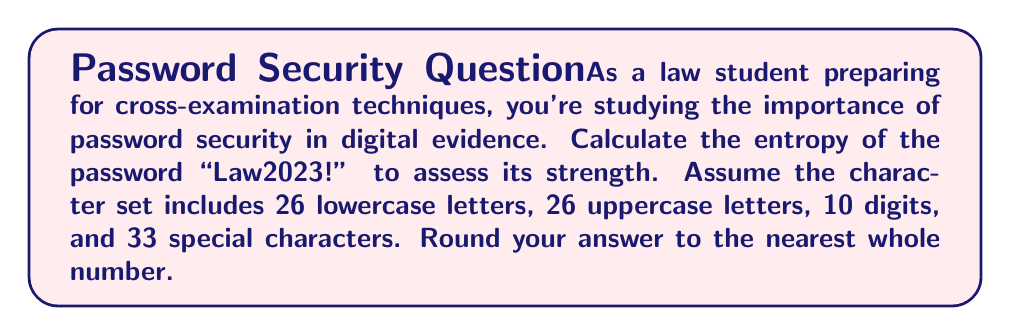Could you help me with this problem? To calculate the entropy of a password, we use the formula:

$$H = L \times \log_2(R)$$

Where:
$H$ = entropy in bits
$L$ = length of the password
$R$ = size of the character set

Step 1: Determine the length of the password (L)
The password "Law2023!" has 8 characters, so $L = 8$.

Step 2: Determine the size of the character set (R)
The character set includes:
- 26 lowercase letters
- 26 uppercase letters
- 10 digits
- 33 special characters

Total: $R = 26 + 26 + 10 + 33 = 95$

Step 3: Apply the formula
$$H = 8 \times \log_2(95)$$

Step 4: Calculate $\log_2(95)$
$$\log_2(95) \approx 6.5699$$

Step 5: Multiply by the password length
$$H = 8 \times 6.5699 \approx 52.5592$$

Step 6: Round to the nearest whole number
$$H \approx 53$$

Therefore, the entropy of the password "Law2023!" is approximately 53 bits.
Answer: 53 bits 